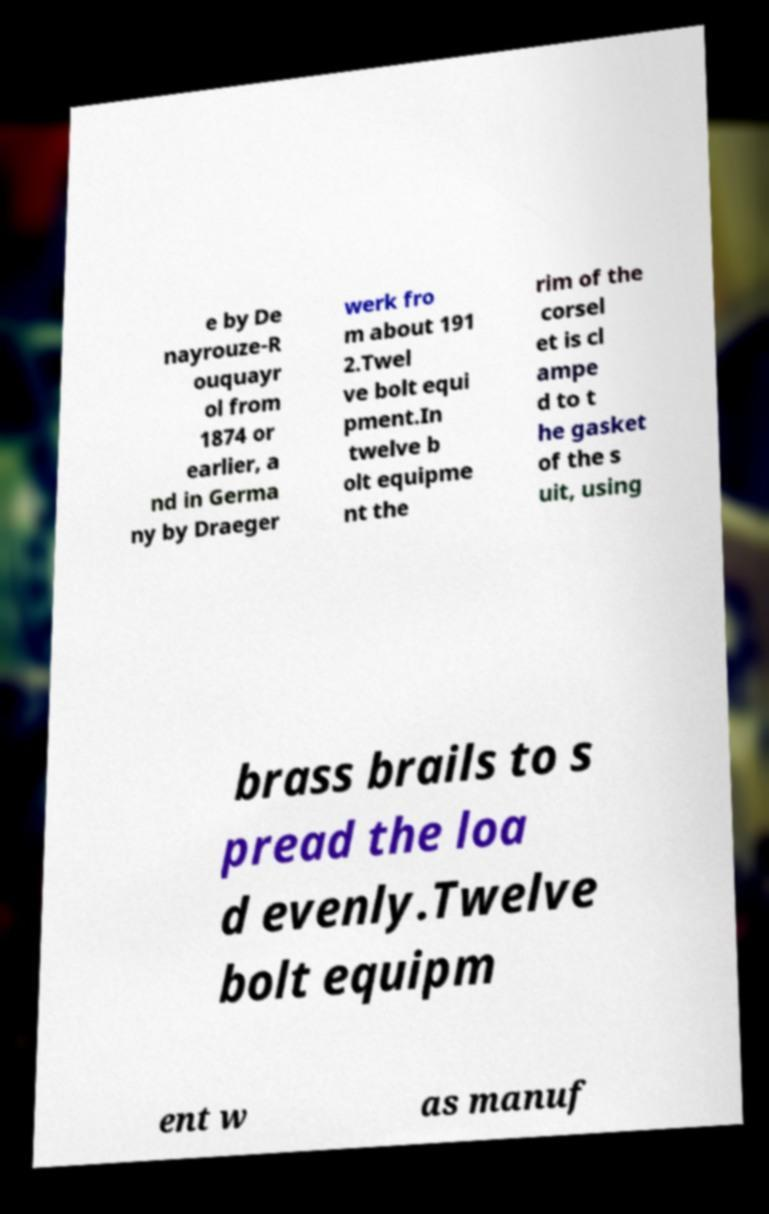I need the written content from this picture converted into text. Can you do that? e by De nayrouze-R ouquayr ol from 1874 or earlier, a nd in Germa ny by Draeger werk fro m about 191 2.Twel ve bolt equi pment.In twelve b olt equipme nt the rim of the corsel et is cl ampe d to t he gasket of the s uit, using brass brails to s pread the loa d evenly.Twelve bolt equipm ent w as manuf 